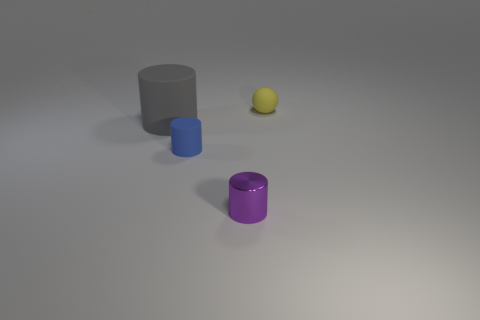There is a small sphere that is the same material as the blue thing; what color is it?
Provide a short and direct response. Yellow. Is there anything else that is the same size as the gray thing?
Ensure brevity in your answer.  No. There is a purple metal cylinder; what number of rubber things are on the left side of it?
Offer a very short reply. 2. Do the object to the right of the small purple thing and the cylinder right of the blue matte cylinder have the same color?
Keep it short and to the point. No. What is the color of the tiny rubber thing that is the same shape as the purple metallic thing?
Give a very brief answer. Blue. Is there anything else that has the same shape as the gray object?
Your response must be concise. Yes. There is a tiny rubber thing that is in front of the matte ball; is it the same shape as the tiny rubber thing that is behind the big gray thing?
Offer a terse response. No. There is a blue thing; is its size the same as the matte object behind the large gray cylinder?
Your answer should be compact. Yes. Are there more tiny metallic cylinders than yellow shiny spheres?
Give a very brief answer. Yes. Do the object that is behind the large gray rubber cylinder and the purple cylinder in front of the big gray cylinder have the same material?
Give a very brief answer. No. 